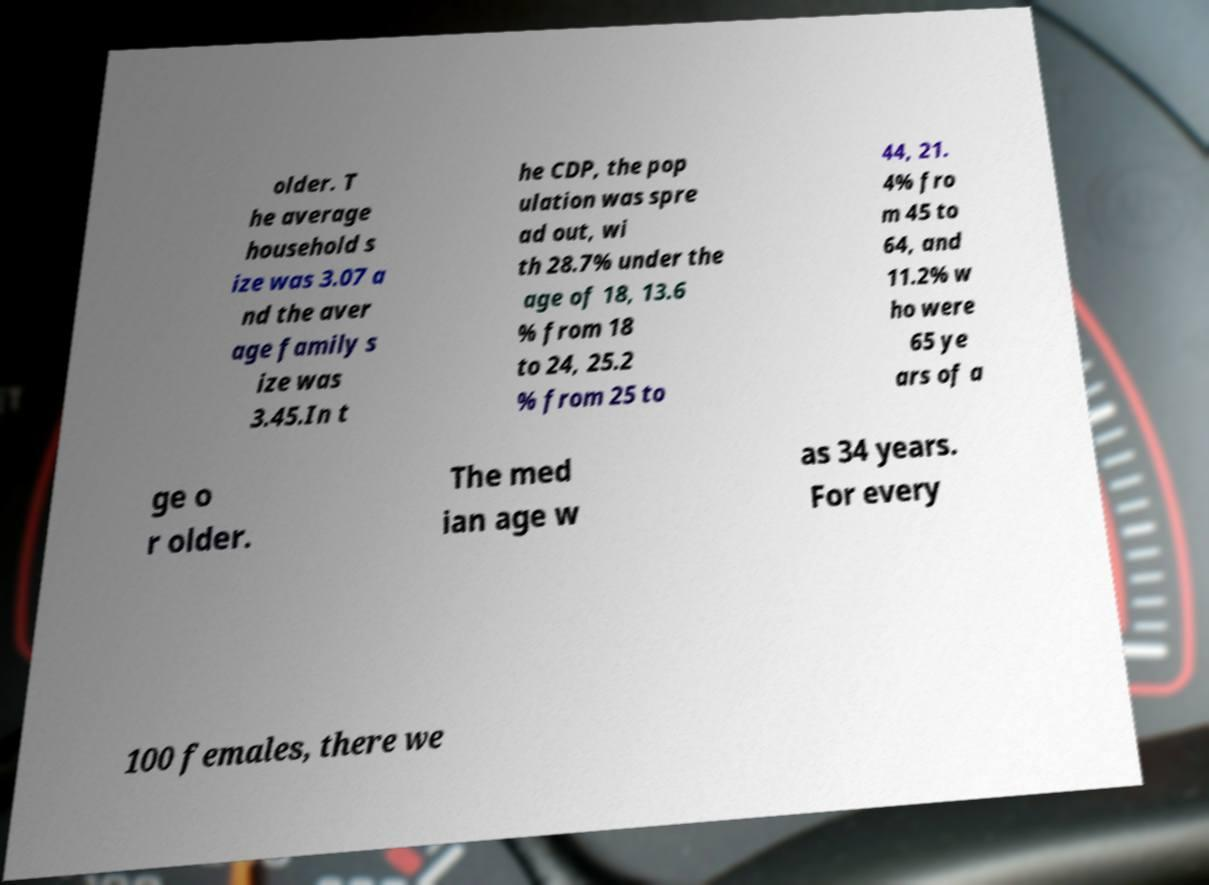Please identify and transcribe the text found in this image. older. T he average household s ize was 3.07 a nd the aver age family s ize was 3.45.In t he CDP, the pop ulation was spre ad out, wi th 28.7% under the age of 18, 13.6 % from 18 to 24, 25.2 % from 25 to 44, 21. 4% fro m 45 to 64, and 11.2% w ho were 65 ye ars of a ge o r older. The med ian age w as 34 years. For every 100 females, there we 